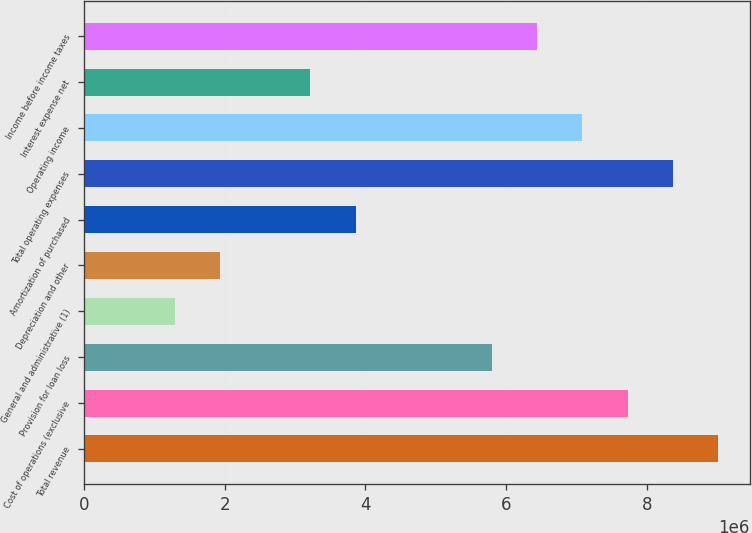Convert chart. <chart><loc_0><loc_0><loc_500><loc_500><bar_chart><fcel>Total revenue<fcel>Cost of operations (exclusive<fcel>Provision for loan loss<fcel>General and administrative (1)<fcel>Depreciation and other<fcel>Amortization of purchased<fcel>Total operating expenses<fcel>Operating income<fcel>Interest expense net<fcel>Income before income taxes<nl><fcel>9.01564e+06<fcel>7.72769e+06<fcel>5.79577e+06<fcel>1.28796e+06<fcel>1.93193e+06<fcel>3.86385e+06<fcel>8.37167e+06<fcel>7.08372e+06<fcel>3.21988e+06<fcel>6.43975e+06<nl></chart> 